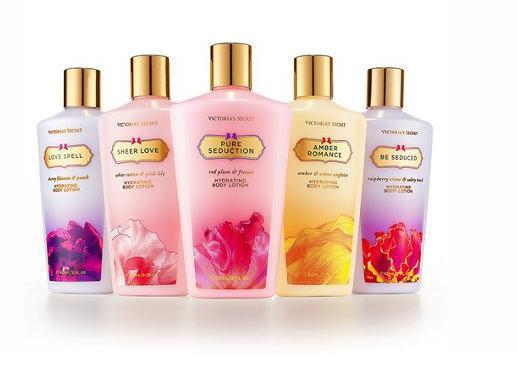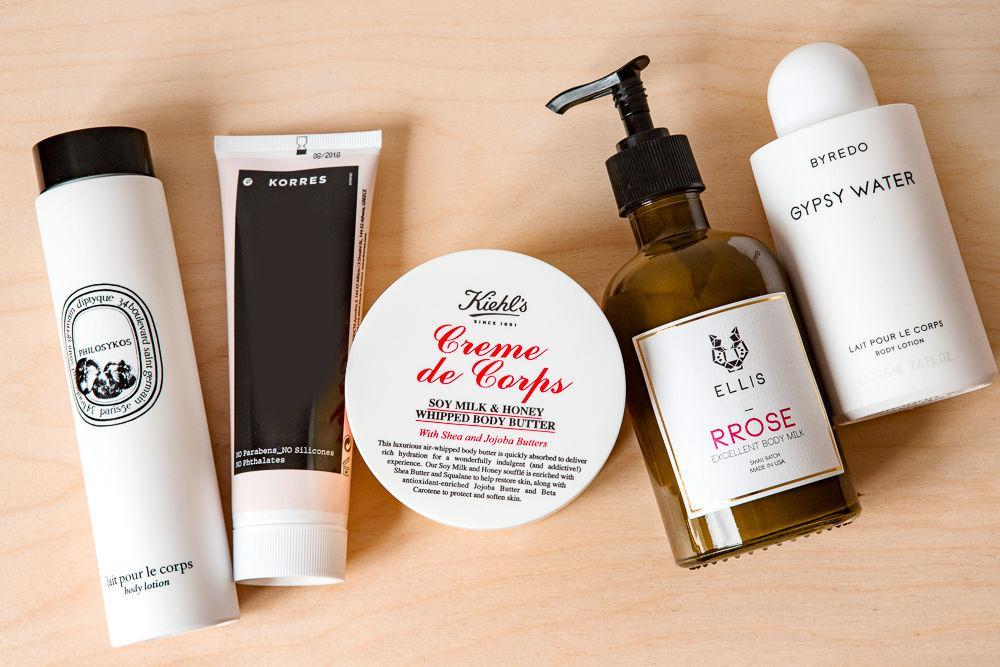The first image is the image on the left, the second image is the image on the right. Analyze the images presented: Is the assertion "A grouping of skincare products includes at least one round shallow jar." valid? Answer yes or no. Yes. 